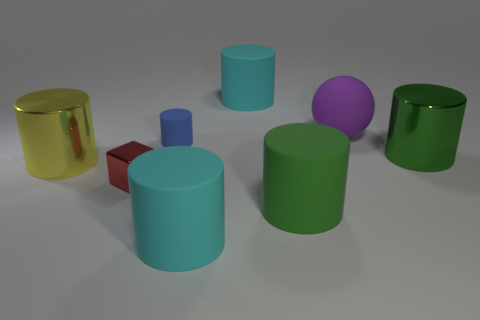What is the color of the large metallic cylinder that is in front of the big metal thing behind the yellow shiny cylinder?
Your response must be concise. Yellow. What number of cylinders are both left of the red object and behind the purple rubber thing?
Your response must be concise. 0. Is the number of big metal objects greater than the number of gray balls?
Provide a succinct answer. Yes. What is the big sphere made of?
Make the answer very short. Rubber. There is a big cyan matte thing in front of the tiny shiny cube; what number of blue objects are right of it?
Your answer should be very brief. 0. There is a large sphere; is its color the same as the thing in front of the big green matte cylinder?
Give a very brief answer. No. There is a sphere that is the same size as the green rubber cylinder; what color is it?
Your answer should be very brief. Purple. Are there any small blue matte things of the same shape as the large green shiny thing?
Give a very brief answer. Yes. Is the number of green blocks less than the number of cyan matte objects?
Offer a terse response. Yes. What is the color of the small object in front of the large yellow cylinder?
Provide a short and direct response. Red. 